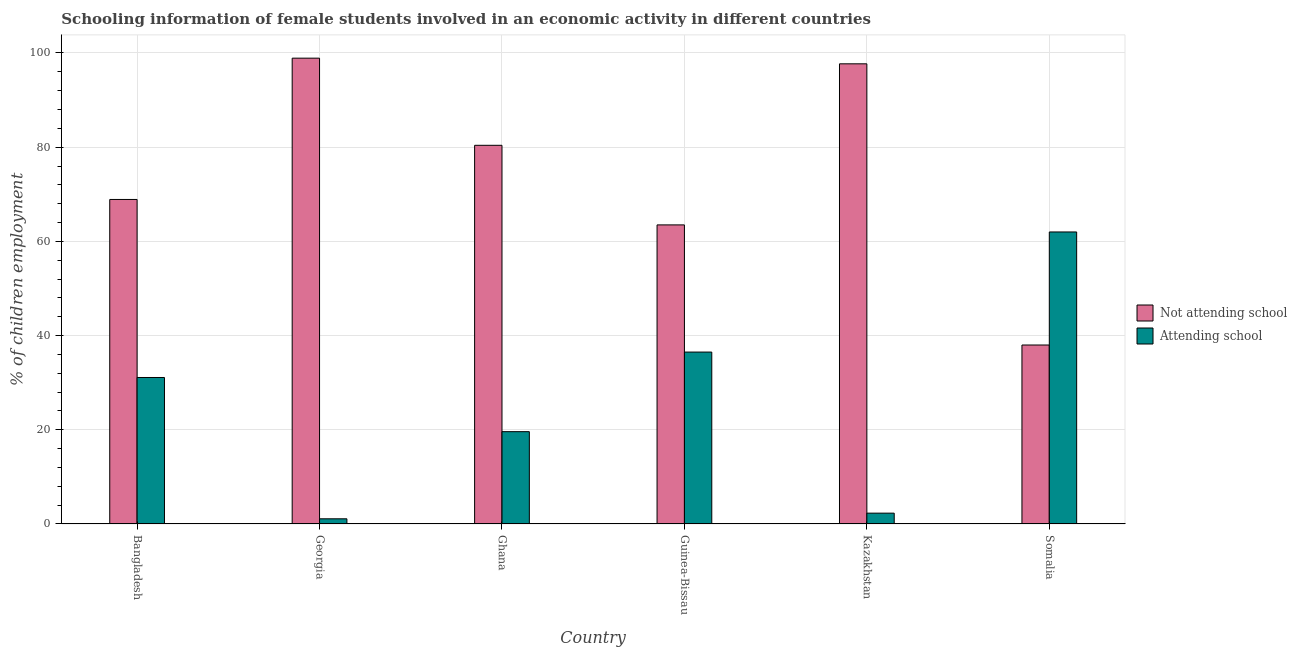How many groups of bars are there?
Your answer should be very brief. 6. Are the number of bars on each tick of the X-axis equal?
Offer a very short reply. Yes. How many bars are there on the 5th tick from the left?
Give a very brief answer. 2. What is the label of the 5th group of bars from the left?
Provide a succinct answer. Kazakhstan. What is the percentage of employed females who are attending school in Guinea-Bissau?
Give a very brief answer. 36.5. Across all countries, what is the maximum percentage of employed females who are not attending school?
Make the answer very short. 98.9. In which country was the percentage of employed females who are not attending school maximum?
Your answer should be very brief. Georgia. In which country was the percentage of employed females who are not attending school minimum?
Your response must be concise. Somalia. What is the total percentage of employed females who are not attending school in the graph?
Your answer should be compact. 447.4. What is the difference between the percentage of employed females who are attending school in Ghana and that in Kazakhstan?
Offer a terse response. 17.3. What is the average percentage of employed females who are not attending school per country?
Your response must be concise. 74.57. What is the difference between the percentage of employed females who are not attending school and percentage of employed females who are attending school in Ghana?
Your response must be concise. 60.8. What is the ratio of the percentage of employed females who are not attending school in Kazakhstan to that in Somalia?
Keep it short and to the point. 2.57. Is the difference between the percentage of employed females who are not attending school in Ghana and Guinea-Bissau greater than the difference between the percentage of employed females who are attending school in Ghana and Guinea-Bissau?
Your response must be concise. Yes. What is the difference between the highest and the second highest percentage of employed females who are attending school?
Your answer should be very brief. 25.5. What is the difference between the highest and the lowest percentage of employed females who are attending school?
Keep it short and to the point. 60.9. In how many countries, is the percentage of employed females who are attending school greater than the average percentage of employed females who are attending school taken over all countries?
Make the answer very short. 3. Is the sum of the percentage of employed females who are not attending school in Bangladesh and Ghana greater than the maximum percentage of employed females who are attending school across all countries?
Keep it short and to the point. Yes. What does the 1st bar from the left in Georgia represents?
Offer a terse response. Not attending school. What does the 2nd bar from the right in Georgia represents?
Your response must be concise. Not attending school. How many bars are there?
Your response must be concise. 12. Are all the bars in the graph horizontal?
Provide a succinct answer. No. How many countries are there in the graph?
Your answer should be compact. 6. Does the graph contain any zero values?
Keep it short and to the point. No. How many legend labels are there?
Your answer should be compact. 2. How are the legend labels stacked?
Give a very brief answer. Vertical. What is the title of the graph?
Provide a short and direct response. Schooling information of female students involved in an economic activity in different countries. What is the label or title of the Y-axis?
Make the answer very short. % of children employment. What is the % of children employment in Not attending school in Bangladesh?
Your response must be concise. 68.9. What is the % of children employment in Attending school in Bangladesh?
Give a very brief answer. 31.1. What is the % of children employment of Not attending school in Georgia?
Your answer should be compact. 98.9. What is the % of children employment of Not attending school in Ghana?
Your answer should be compact. 80.4. What is the % of children employment of Attending school in Ghana?
Provide a succinct answer. 19.6. What is the % of children employment in Not attending school in Guinea-Bissau?
Offer a terse response. 63.5. What is the % of children employment of Attending school in Guinea-Bissau?
Your answer should be compact. 36.5. What is the % of children employment of Not attending school in Kazakhstan?
Your response must be concise. 97.7. Across all countries, what is the maximum % of children employment of Not attending school?
Your answer should be very brief. 98.9. Across all countries, what is the maximum % of children employment of Attending school?
Make the answer very short. 62. Across all countries, what is the minimum % of children employment of Not attending school?
Make the answer very short. 38. Across all countries, what is the minimum % of children employment of Attending school?
Provide a short and direct response. 1.1. What is the total % of children employment in Not attending school in the graph?
Ensure brevity in your answer.  447.4. What is the total % of children employment of Attending school in the graph?
Provide a succinct answer. 152.6. What is the difference between the % of children employment in Attending school in Bangladesh and that in Georgia?
Your answer should be very brief. 30. What is the difference between the % of children employment of Attending school in Bangladesh and that in Ghana?
Offer a very short reply. 11.5. What is the difference between the % of children employment in Attending school in Bangladesh and that in Guinea-Bissau?
Provide a succinct answer. -5.4. What is the difference between the % of children employment of Not attending school in Bangladesh and that in Kazakhstan?
Offer a very short reply. -28.8. What is the difference between the % of children employment in Attending school in Bangladesh and that in Kazakhstan?
Your answer should be very brief. 28.8. What is the difference between the % of children employment of Not attending school in Bangladesh and that in Somalia?
Ensure brevity in your answer.  30.9. What is the difference between the % of children employment of Attending school in Bangladesh and that in Somalia?
Provide a short and direct response. -30.9. What is the difference between the % of children employment in Attending school in Georgia and that in Ghana?
Keep it short and to the point. -18.5. What is the difference between the % of children employment in Not attending school in Georgia and that in Guinea-Bissau?
Make the answer very short. 35.4. What is the difference between the % of children employment in Attending school in Georgia and that in Guinea-Bissau?
Make the answer very short. -35.4. What is the difference between the % of children employment in Not attending school in Georgia and that in Somalia?
Provide a succinct answer. 60.9. What is the difference between the % of children employment of Attending school in Georgia and that in Somalia?
Your answer should be compact. -60.9. What is the difference between the % of children employment of Not attending school in Ghana and that in Guinea-Bissau?
Ensure brevity in your answer.  16.9. What is the difference between the % of children employment of Attending school in Ghana and that in Guinea-Bissau?
Offer a very short reply. -16.9. What is the difference between the % of children employment of Not attending school in Ghana and that in Kazakhstan?
Your answer should be compact. -17.3. What is the difference between the % of children employment in Not attending school in Ghana and that in Somalia?
Offer a terse response. 42.4. What is the difference between the % of children employment of Attending school in Ghana and that in Somalia?
Your answer should be very brief. -42.4. What is the difference between the % of children employment of Not attending school in Guinea-Bissau and that in Kazakhstan?
Keep it short and to the point. -34.2. What is the difference between the % of children employment in Attending school in Guinea-Bissau and that in Kazakhstan?
Your answer should be compact. 34.2. What is the difference between the % of children employment of Not attending school in Guinea-Bissau and that in Somalia?
Offer a terse response. 25.5. What is the difference between the % of children employment of Attending school in Guinea-Bissau and that in Somalia?
Your answer should be very brief. -25.5. What is the difference between the % of children employment of Not attending school in Kazakhstan and that in Somalia?
Give a very brief answer. 59.7. What is the difference between the % of children employment of Attending school in Kazakhstan and that in Somalia?
Provide a short and direct response. -59.7. What is the difference between the % of children employment of Not attending school in Bangladesh and the % of children employment of Attending school in Georgia?
Your answer should be compact. 67.8. What is the difference between the % of children employment in Not attending school in Bangladesh and the % of children employment in Attending school in Ghana?
Your answer should be compact. 49.3. What is the difference between the % of children employment in Not attending school in Bangladesh and the % of children employment in Attending school in Guinea-Bissau?
Your answer should be compact. 32.4. What is the difference between the % of children employment of Not attending school in Bangladesh and the % of children employment of Attending school in Kazakhstan?
Keep it short and to the point. 66.6. What is the difference between the % of children employment of Not attending school in Georgia and the % of children employment of Attending school in Ghana?
Make the answer very short. 79.3. What is the difference between the % of children employment in Not attending school in Georgia and the % of children employment in Attending school in Guinea-Bissau?
Provide a short and direct response. 62.4. What is the difference between the % of children employment of Not attending school in Georgia and the % of children employment of Attending school in Kazakhstan?
Ensure brevity in your answer.  96.6. What is the difference between the % of children employment of Not attending school in Georgia and the % of children employment of Attending school in Somalia?
Provide a succinct answer. 36.9. What is the difference between the % of children employment in Not attending school in Ghana and the % of children employment in Attending school in Guinea-Bissau?
Keep it short and to the point. 43.9. What is the difference between the % of children employment in Not attending school in Ghana and the % of children employment in Attending school in Kazakhstan?
Your answer should be compact. 78.1. What is the difference between the % of children employment in Not attending school in Guinea-Bissau and the % of children employment in Attending school in Kazakhstan?
Offer a terse response. 61.2. What is the difference between the % of children employment of Not attending school in Guinea-Bissau and the % of children employment of Attending school in Somalia?
Your response must be concise. 1.5. What is the difference between the % of children employment of Not attending school in Kazakhstan and the % of children employment of Attending school in Somalia?
Your response must be concise. 35.7. What is the average % of children employment of Not attending school per country?
Provide a succinct answer. 74.57. What is the average % of children employment of Attending school per country?
Your answer should be very brief. 25.43. What is the difference between the % of children employment of Not attending school and % of children employment of Attending school in Bangladesh?
Ensure brevity in your answer.  37.8. What is the difference between the % of children employment of Not attending school and % of children employment of Attending school in Georgia?
Your answer should be very brief. 97.8. What is the difference between the % of children employment in Not attending school and % of children employment in Attending school in Ghana?
Give a very brief answer. 60.8. What is the difference between the % of children employment of Not attending school and % of children employment of Attending school in Guinea-Bissau?
Give a very brief answer. 27. What is the difference between the % of children employment in Not attending school and % of children employment in Attending school in Kazakhstan?
Your answer should be compact. 95.4. What is the ratio of the % of children employment of Not attending school in Bangladesh to that in Georgia?
Offer a very short reply. 0.7. What is the ratio of the % of children employment of Attending school in Bangladesh to that in Georgia?
Keep it short and to the point. 28.27. What is the ratio of the % of children employment of Not attending school in Bangladesh to that in Ghana?
Your answer should be compact. 0.86. What is the ratio of the % of children employment in Attending school in Bangladesh to that in Ghana?
Provide a short and direct response. 1.59. What is the ratio of the % of children employment of Not attending school in Bangladesh to that in Guinea-Bissau?
Ensure brevity in your answer.  1.08. What is the ratio of the % of children employment of Attending school in Bangladesh to that in Guinea-Bissau?
Give a very brief answer. 0.85. What is the ratio of the % of children employment of Not attending school in Bangladesh to that in Kazakhstan?
Give a very brief answer. 0.71. What is the ratio of the % of children employment of Attending school in Bangladesh to that in Kazakhstan?
Make the answer very short. 13.52. What is the ratio of the % of children employment in Not attending school in Bangladesh to that in Somalia?
Your answer should be compact. 1.81. What is the ratio of the % of children employment of Attending school in Bangladesh to that in Somalia?
Make the answer very short. 0.5. What is the ratio of the % of children employment in Not attending school in Georgia to that in Ghana?
Offer a very short reply. 1.23. What is the ratio of the % of children employment of Attending school in Georgia to that in Ghana?
Your response must be concise. 0.06. What is the ratio of the % of children employment in Not attending school in Georgia to that in Guinea-Bissau?
Your answer should be very brief. 1.56. What is the ratio of the % of children employment of Attending school in Georgia to that in Guinea-Bissau?
Make the answer very short. 0.03. What is the ratio of the % of children employment in Not attending school in Georgia to that in Kazakhstan?
Offer a terse response. 1.01. What is the ratio of the % of children employment in Attending school in Georgia to that in Kazakhstan?
Make the answer very short. 0.48. What is the ratio of the % of children employment of Not attending school in Georgia to that in Somalia?
Provide a succinct answer. 2.6. What is the ratio of the % of children employment in Attending school in Georgia to that in Somalia?
Keep it short and to the point. 0.02. What is the ratio of the % of children employment of Not attending school in Ghana to that in Guinea-Bissau?
Provide a succinct answer. 1.27. What is the ratio of the % of children employment of Attending school in Ghana to that in Guinea-Bissau?
Offer a very short reply. 0.54. What is the ratio of the % of children employment in Not attending school in Ghana to that in Kazakhstan?
Offer a terse response. 0.82. What is the ratio of the % of children employment in Attending school in Ghana to that in Kazakhstan?
Your answer should be very brief. 8.52. What is the ratio of the % of children employment of Not attending school in Ghana to that in Somalia?
Give a very brief answer. 2.12. What is the ratio of the % of children employment of Attending school in Ghana to that in Somalia?
Make the answer very short. 0.32. What is the ratio of the % of children employment of Not attending school in Guinea-Bissau to that in Kazakhstan?
Provide a short and direct response. 0.65. What is the ratio of the % of children employment in Attending school in Guinea-Bissau to that in Kazakhstan?
Your answer should be compact. 15.87. What is the ratio of the % of children employment in Not attending school in Guinea-Bissau to that in Somalia?
Ensure brevity in your answer.  1.67. What is the ratio of the % of children employment in Attending school in Guinea-Bissau to that in Somalia?
Ensure brevity in your answer.  0.59. What is the ratio of the % of children employment in Not attending school in Kazakhstan to that in Somalia?
Offer a very short reply. 2.57. What is the ratio of the % of children employment in Attending school in Kazakhstan to that in Somalia?
Your answer should be compact. 0.04. What is the difference between the highest and the second highest % of children employment of Attending school?
Keep it short and to the point. 25.5. What is the difference between the highest and the lowest % of children employment in Not attending school?
Your response must be concise. 60.9. What is the difference between the highest and the lowest % of children employment of Attending school?
Ensure brevity in your answer.  60.9. 